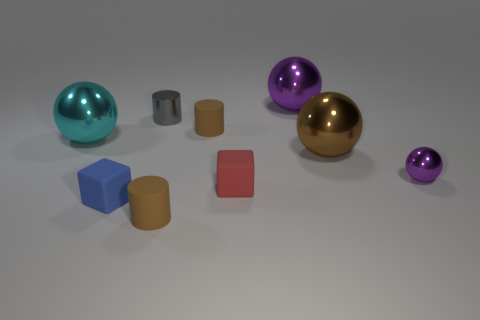Subtract 1 spheres. How many spheres are left? 3 Add 1 gray shiny spheres. How many objects exist? 10 Subtract all cylinders. How many objects are left? 6 Subtract 0 yellow balls. How many objects are left? 9 Subtract all tiny brown cylinders. Subtract all red objects. How many objects are left? 6 Add 8 cyan metallic objects. How many cyan metallic objects are left? 9 Add 9 small green metal spheres. How many small green metal spheres exist? 9 